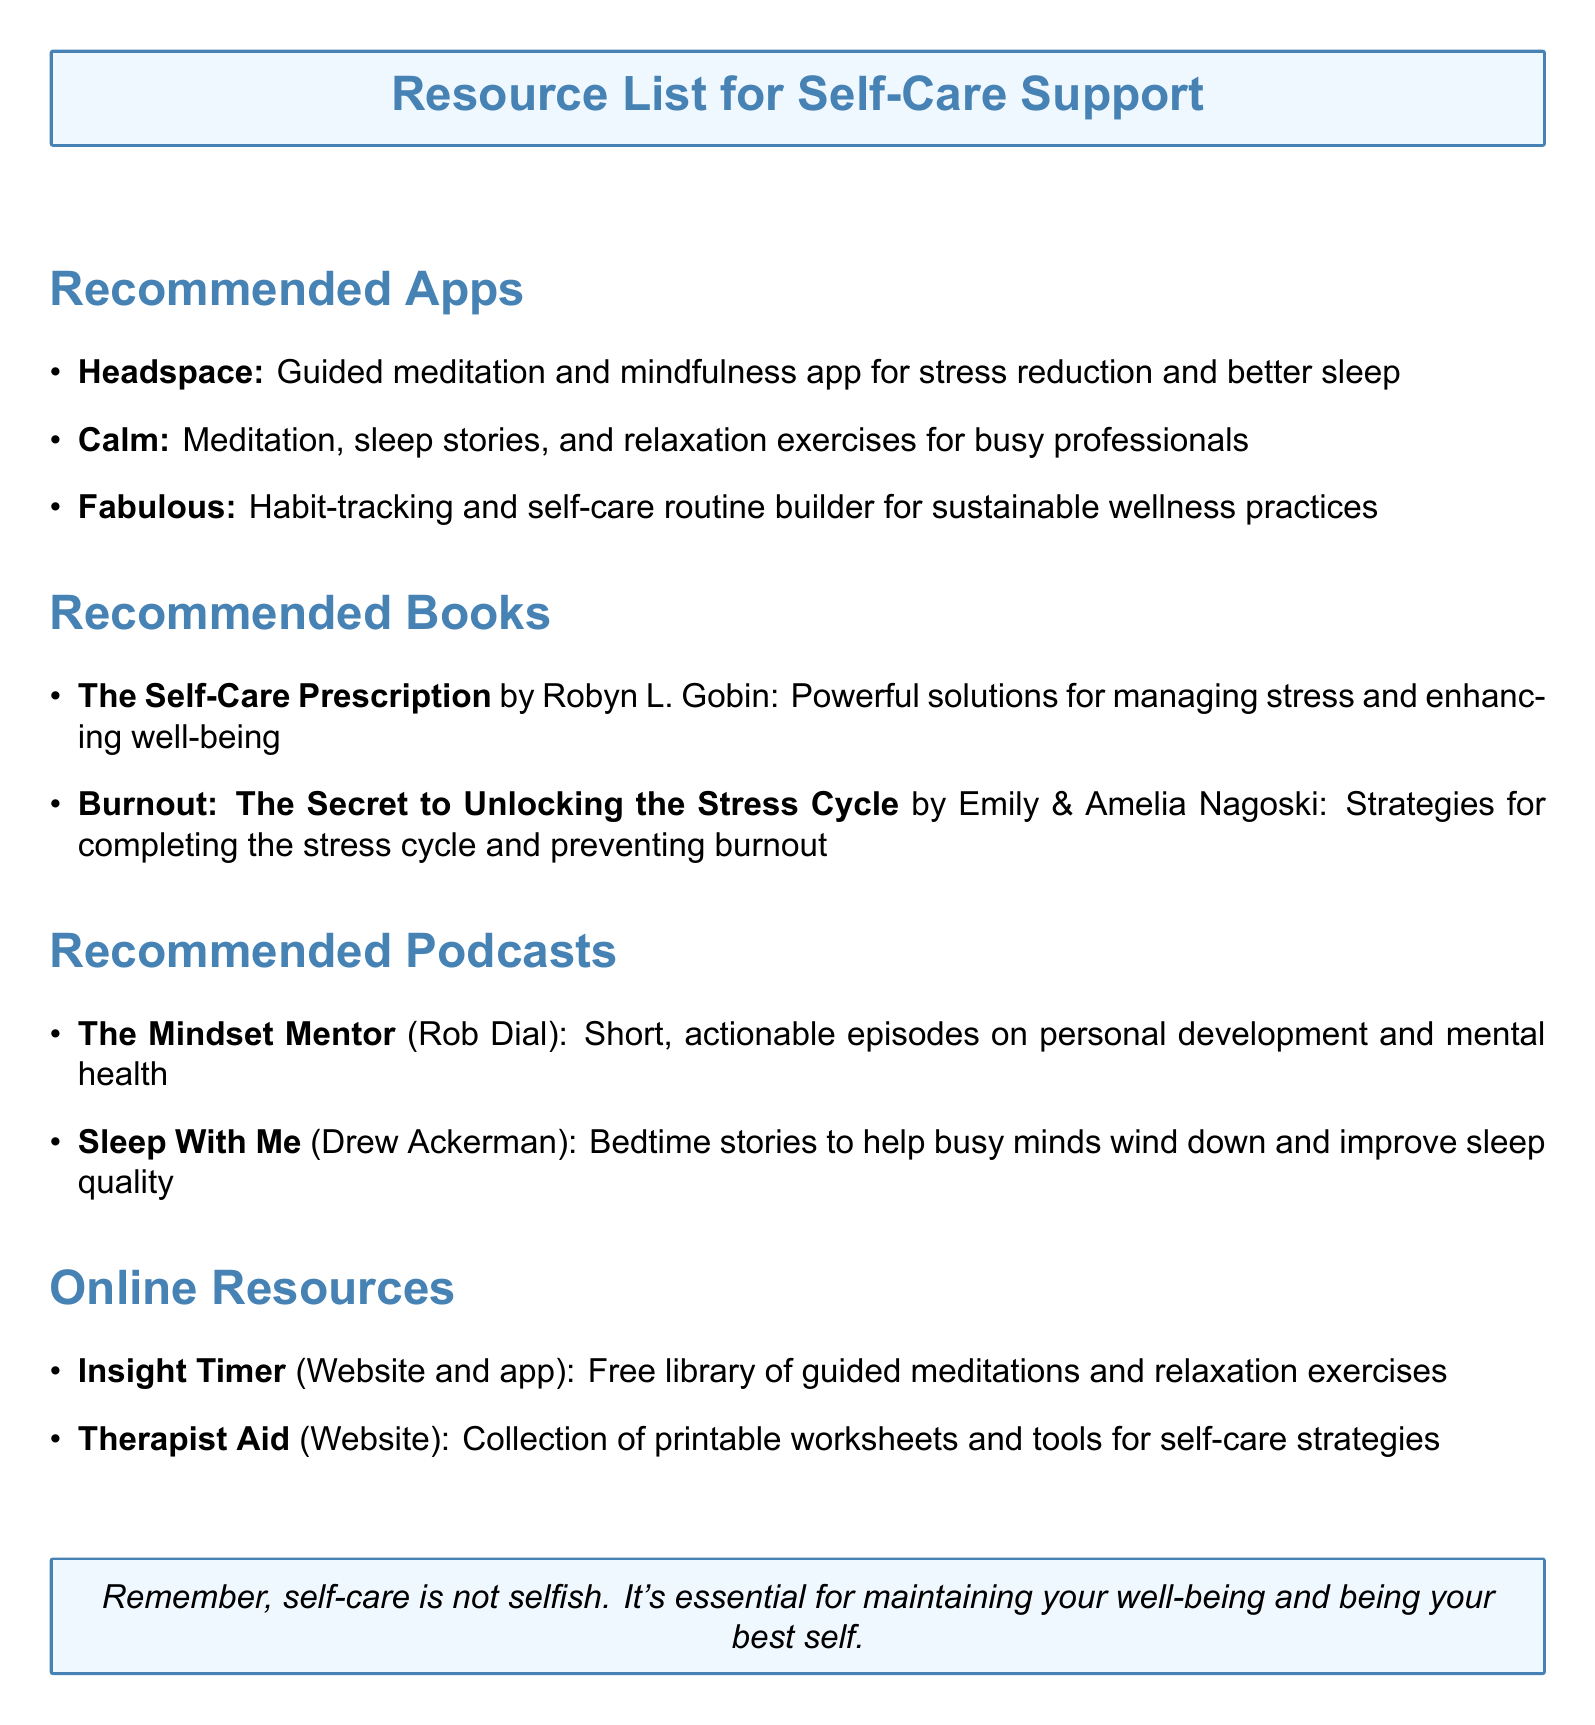What is the first recommended app? The first app listed under recommended apps is "Headspace."
Answer: Headspace Who is the author of "Burnout: The Secret to Unlocking the Stress Cycle"? This book is authored by Emily Nagoski and Amelia Nagoski.
Answer: Emily Nagoski and Amelia Nagoski What type of resource is "Insight Timer"? "Insight Timer" is classified as both a website and an app.
Answer: Website and app How many books are recommended in the document? There are two books listed under the recommended books section.
Answer: 2 What is the main focus of "The Mindset Mentor" podcast? The focus of this podcast is on personal development and mental health.
Answer: personal development and mental health Which app is designed for habit tracking? The app intended for habit tracking and building self-care routines is "Fabulous."
Answer: Fabulous What is the purpose of "Therapist Aid"? "Therapist Aid" provides a collection of printable worksheets and tools for self-care strategies.
Answer: Collection of printable worksheets and tools Which host is associated with the podcast "Sleep With Me"? The host of "Sleep With Me" is Drew Ackerman.
Answer: Drew Ackerman 